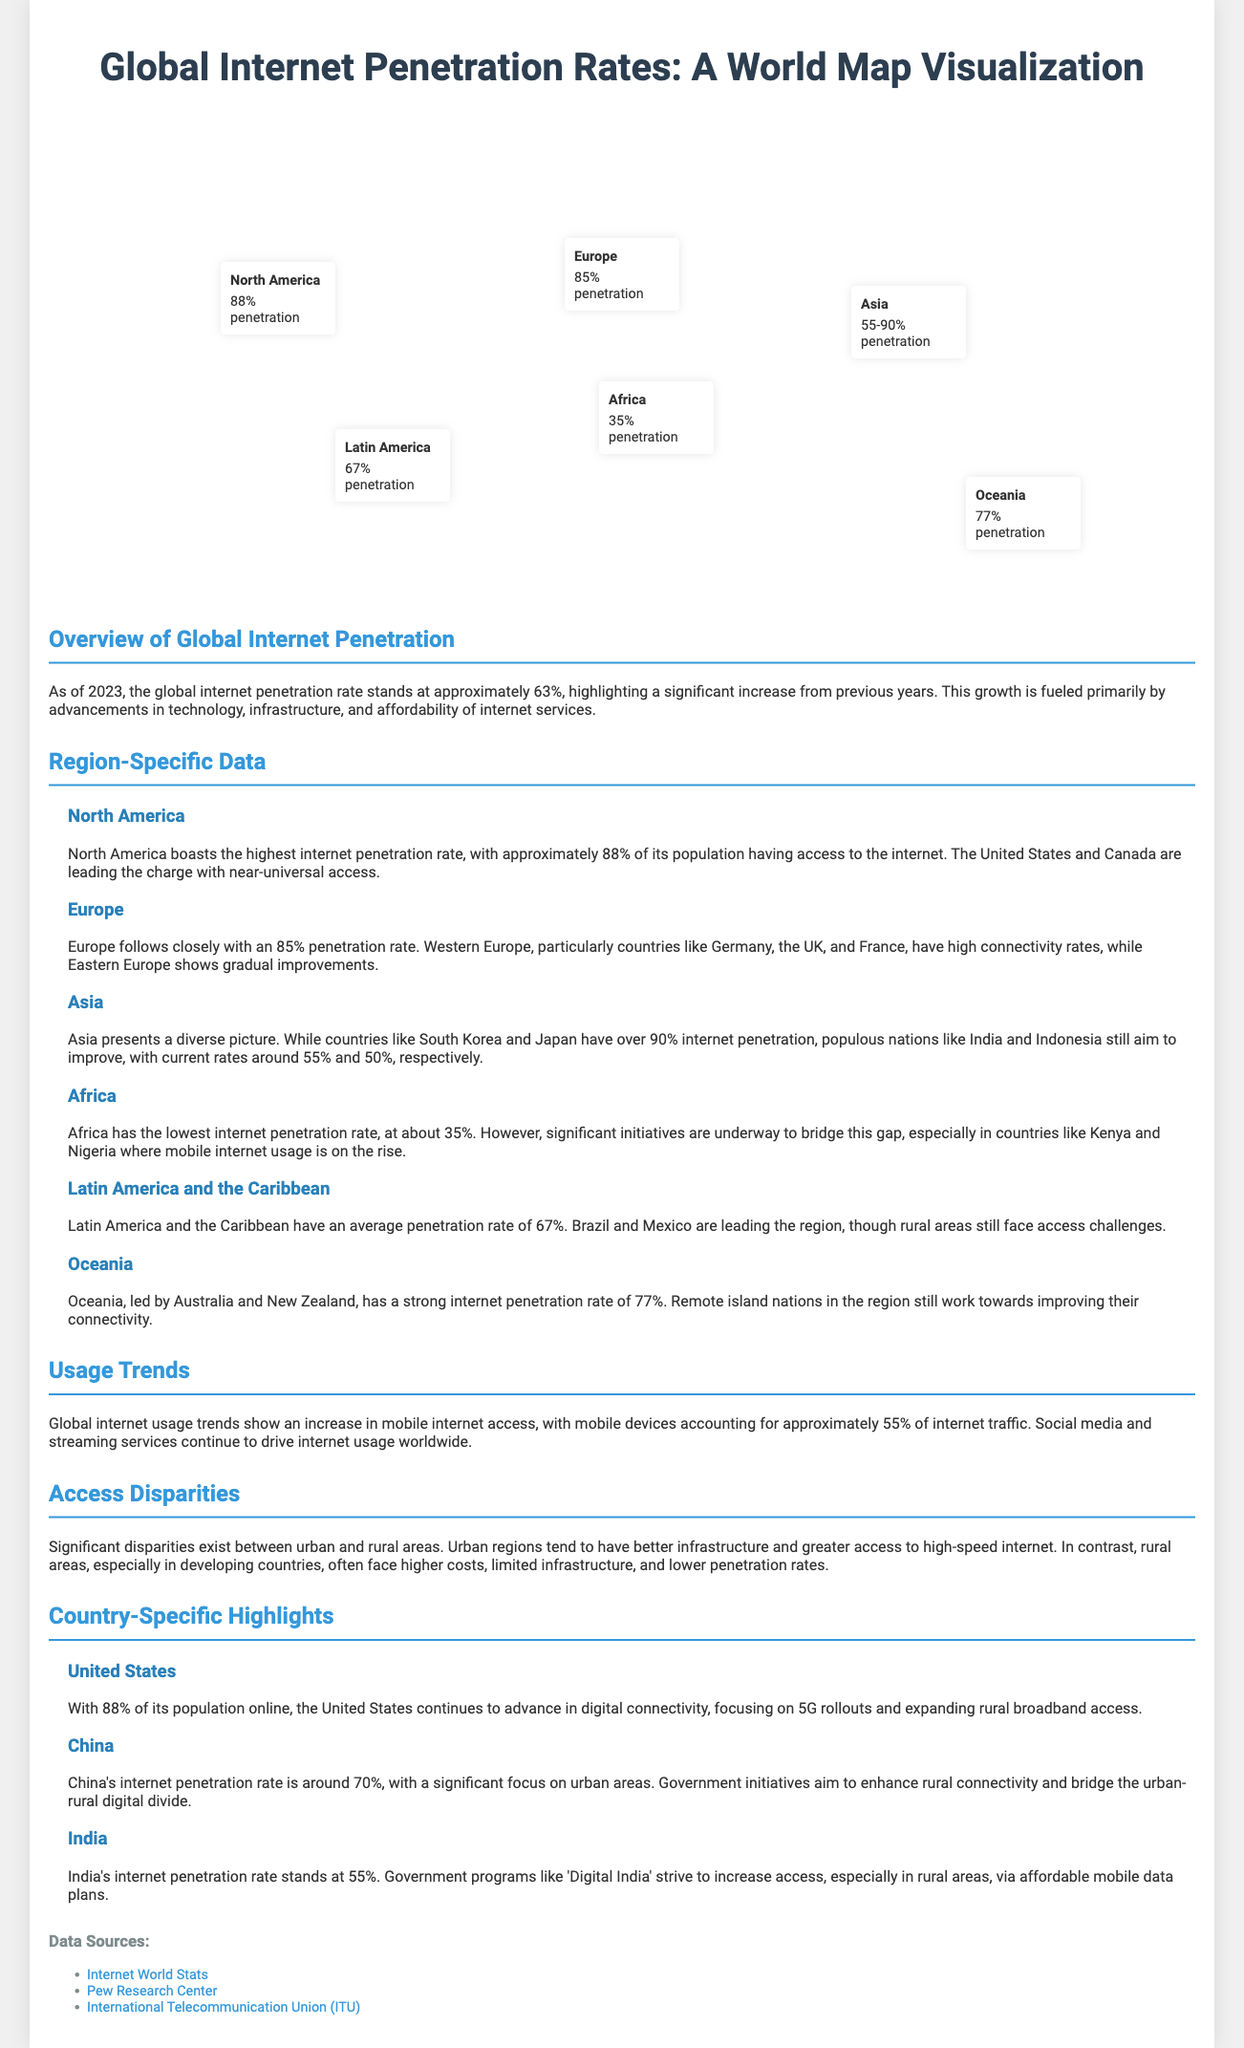What is the global internet penetration rate as of 2023? The global internet penetration rate stands at approximately 63%.
Answer: 63% What region has the highest internet penetration rate? North America boasts the highest internet penetration rate of approximately 88%.
Answer: North America What is Africa's internet penetration rate? Africa has the lowest internet penetration rate, at about 35%.
Answer: 35% Which two countries lead North America in internet access? The United States and Canada are leading the charge with near-universal access.
Answer: United States and Canada What percentage of global internet traffic is from mobile devices? Mobile devices account for approximately 55% of internet traffic.
Answer: 55% What initiative does India have to increase internet access? Government programs like 'Digital India' strive to increase access, especially in rural areas.
Answer: Digital India Which region shows gradual improvements in internet connectivity? Eastern Europe shows gradual improvements in internet connectivity.
Answer: Eastern Europe What is the average internet penetration rate in Latin America and the Caribbean? Latin America and the Caribbean have an average penetration rate of 67%.
Answer: 67% Which two countries are mentioned as facing access challenges in Latin America? Brazil and Mexico are leading the region, though rural areas still face access challenges.
Answer: Brazil and Mexico 